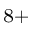Convert formula to latex. <formula><loc_0><loc_0><loc_500><loc_500>^ { 8 + }</formula> 